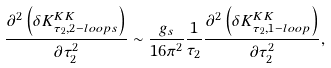Convert formula to latex. <formula><loc_0><loc_0><loc_500><loc_500>\frac { \partial ^ { 2 } \left ( \delta K _ { \tau _ { 2 } , 2 - l o o p s } ^ { K K } \right ) } { \partial \tau _ { 2 } ^ { 2 } } \sim \frac { g _ { s } } { 1 6 \pi ^ { 2 } } \frac { 1 } { \tau _ { 2 } } \frac { \partial ^ { 2 } \left ( \delta K _ { \tau _ { 2 } , 1 - l o o p } ^ { K K } \right ) } { \partial \tau _ { 2 } ^ { 2 } } ,</formula> 